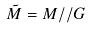<formula> <loc_0><loc_0><loc_500><loc_500>\tilde { M } = M / / G</formula> 